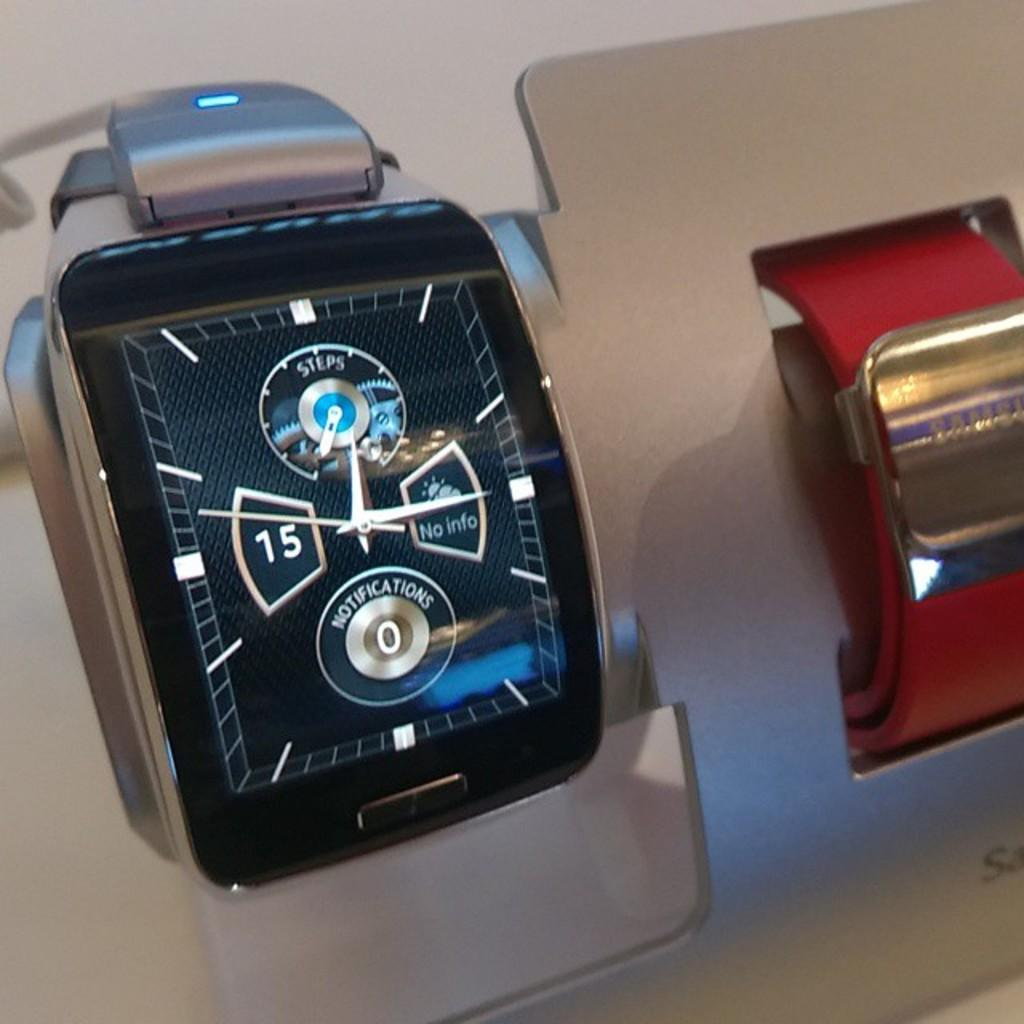Provide a one-sentence caption for the provided image. A smart watch shows no current notifications and no steps. 